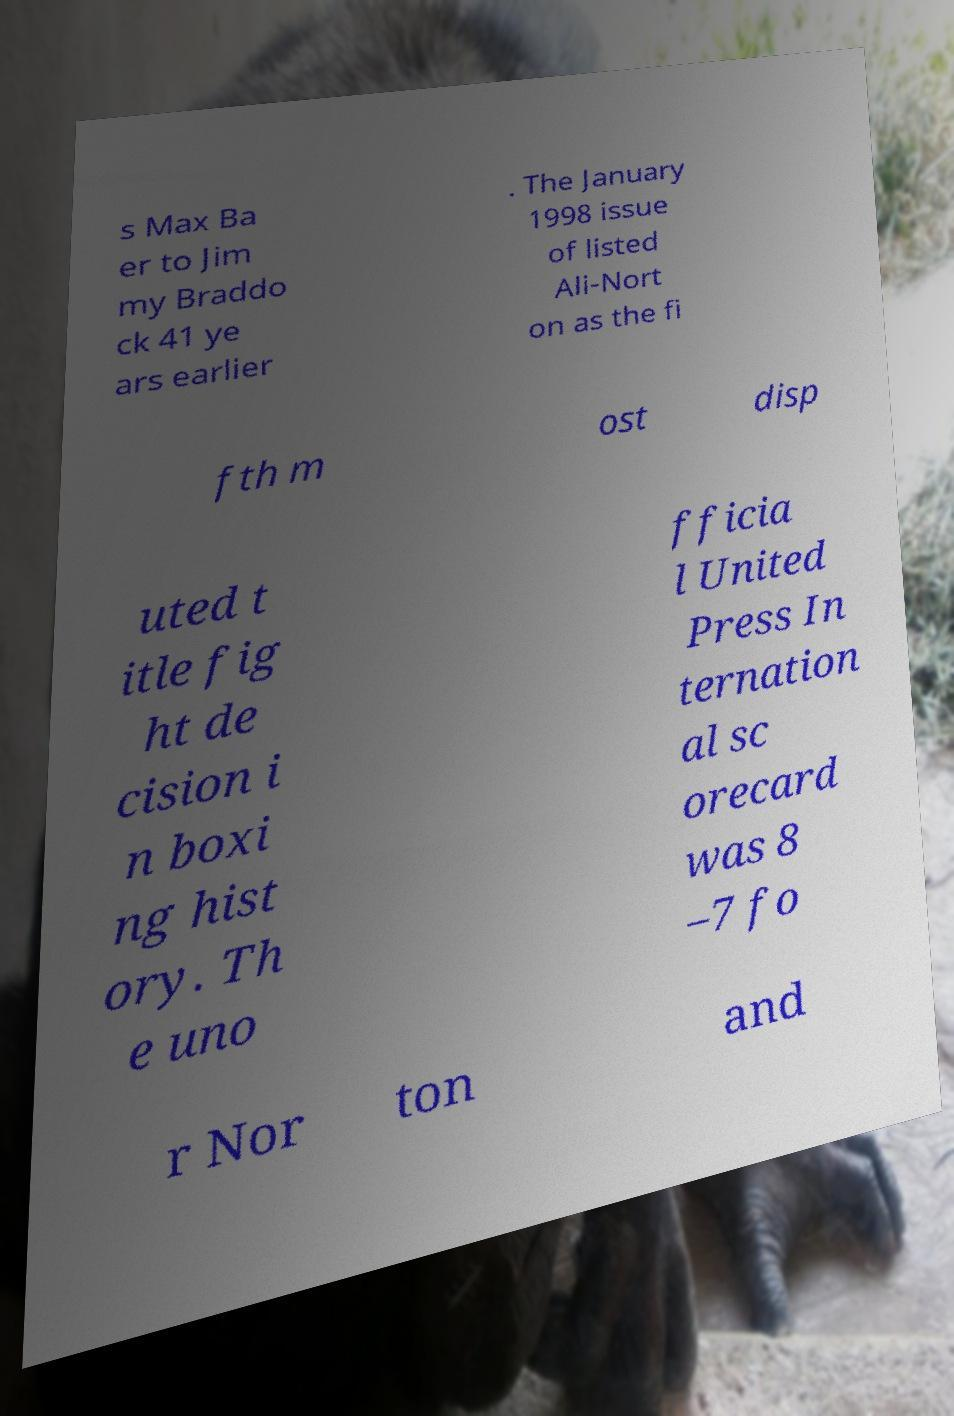I need the written content from this picture converted into text. Can you do that? s Max Ba er to Jim my Braddo ck 41 ye ars earlier . The January 1998 issue of listed Ali-Nort on as the fi fth m ost disp uted t itle fig ht de cision i n boxi ng hist ory. Th e uno fficia l United Press In ternation al sc orecard was 8 –7 fo r Nor ton and 